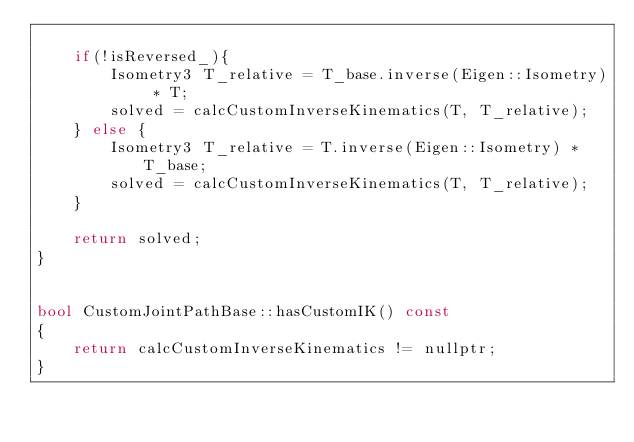<code> <loc_0><loc_0><loc_500><loc_500><_C++_>    
    if(!isReversed_){
        Isometry3 T_relative = T_base.inverse(Eigen::Isometry) * T;
        solved = calcCustomInverseKinematics(T, T_relative);
    } else {
        Isometry3 T_relative = T.inverse(Eigen::Isometry) * T_base;
        solved = calcCustomInverseKinematics(T, T_relative);
    }

    return solved;
}


bool CustomJointPathBase::hasCustomIK() const
{
    return calcCustomInverseKinematics != nullptr;
}
</code> 